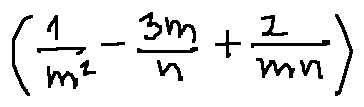<formula> <loc_0><loc_0><loc_500><loc_500>( \frac { 1 } { m ^ { 2 } } - \frac { 3 m } { n } + \frac { 2 } { m _ { n } } )</formula> 